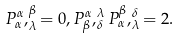<formula> <loc_0><loc_0><loc_500><loc_500>P ^ { \alpha } _ { \alpha } , ^ { \beta } _ { \lambda } = 0 , P ^ { \alpha } _ { \beta } , ^ { \lambda } _ { \delta } P ^ { \beta } _ { \alpha } , ^ { \delta } _ { \lambda } = 2 .</formula> 